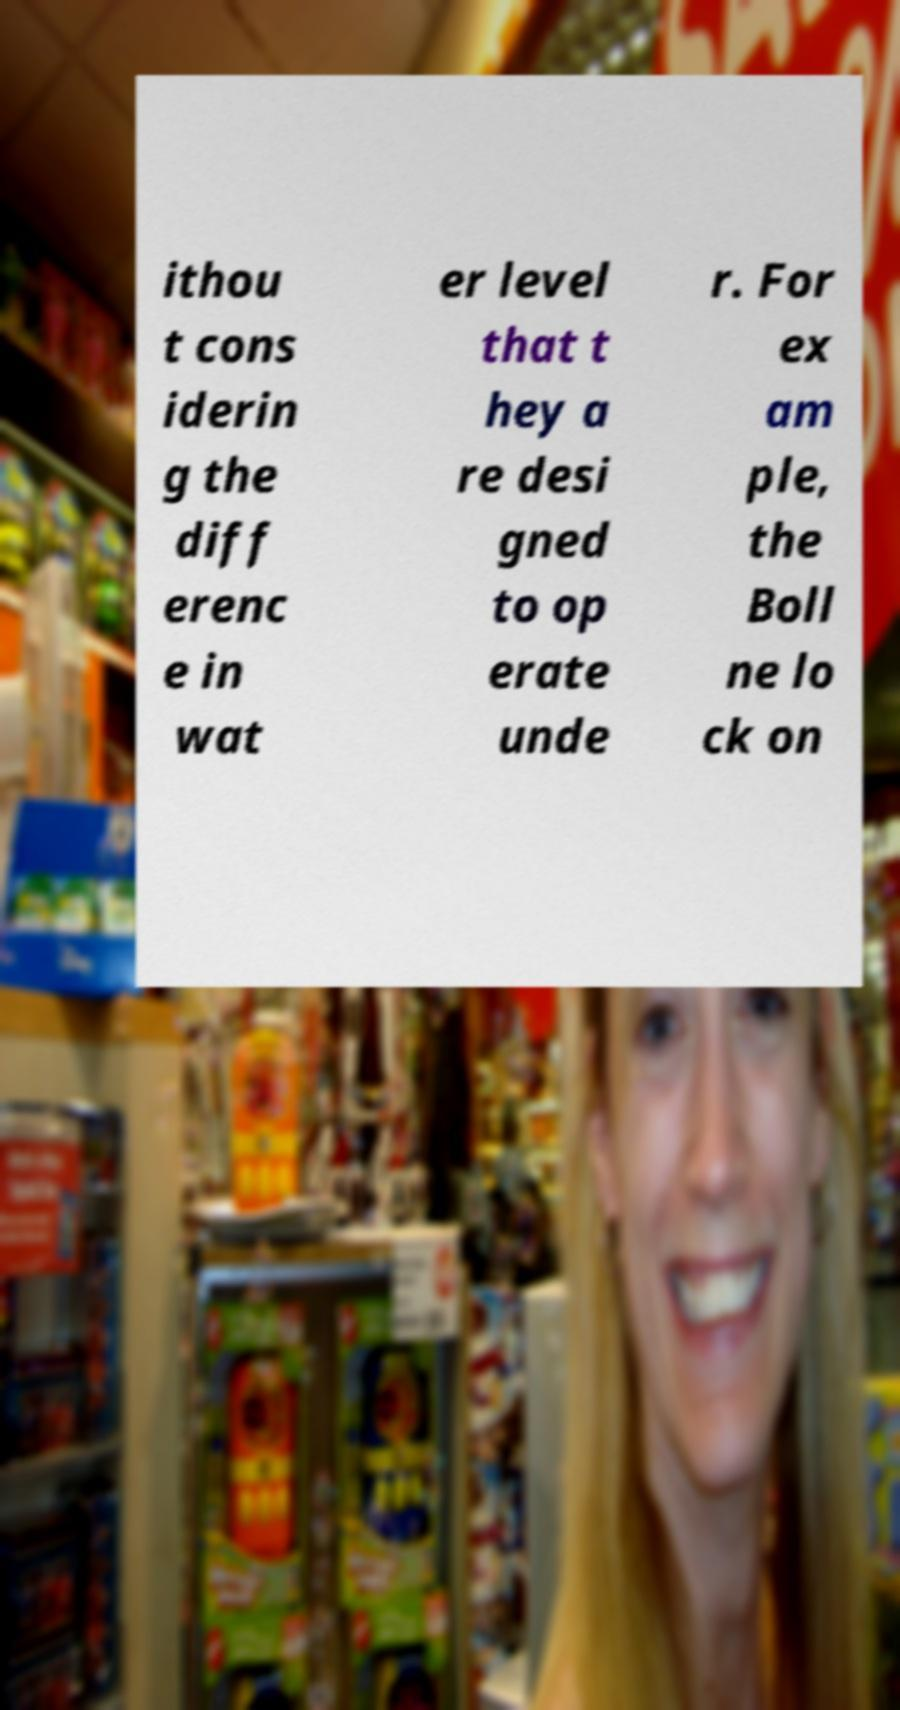For documentation purposes, I need the text within this image transcribed. Could you provide that? ithou t cons iderin g the diff erenc e in wat er level that t hey a re desi gned to op erate unde r. For ex am ple, the Boll ne lo ck on 